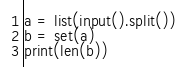<code> <loc_0><loc_0><loc_500><loc_500><_Python_>a = list(input().split())
b = set(a)
print(len(b))</code> 